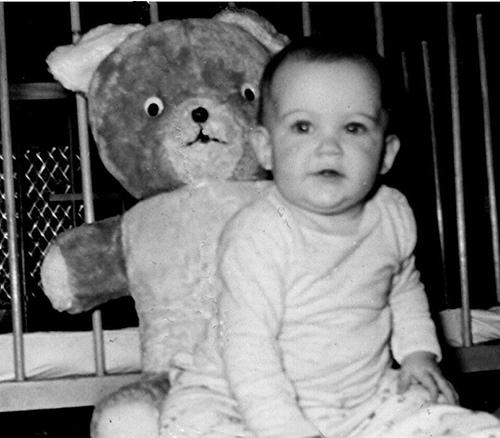Is the baby a boy or a girl?
Write a very short answer. Boy. Is the baby inside the playpen?
Write a very short answer. Yes. Is the child sitting in front of the bear?
Short answer required. Yes. How old is the baby?
Short answer required. 6 months. 